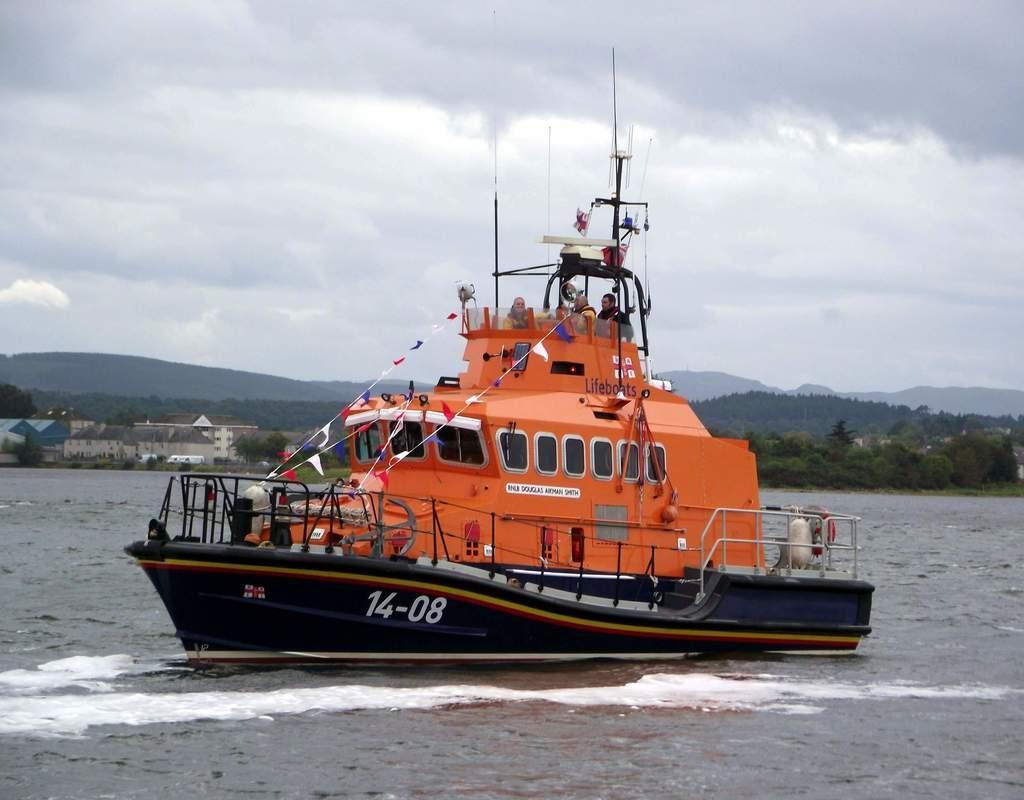How would you summarize this image in a sentence or two? In this image at the bottom there is a river, in that river there is one boat and in the boat there are some persons are some flags, ropes and some objects. And in the background there are some buildings and mountains, at the top of the image there is sky. 